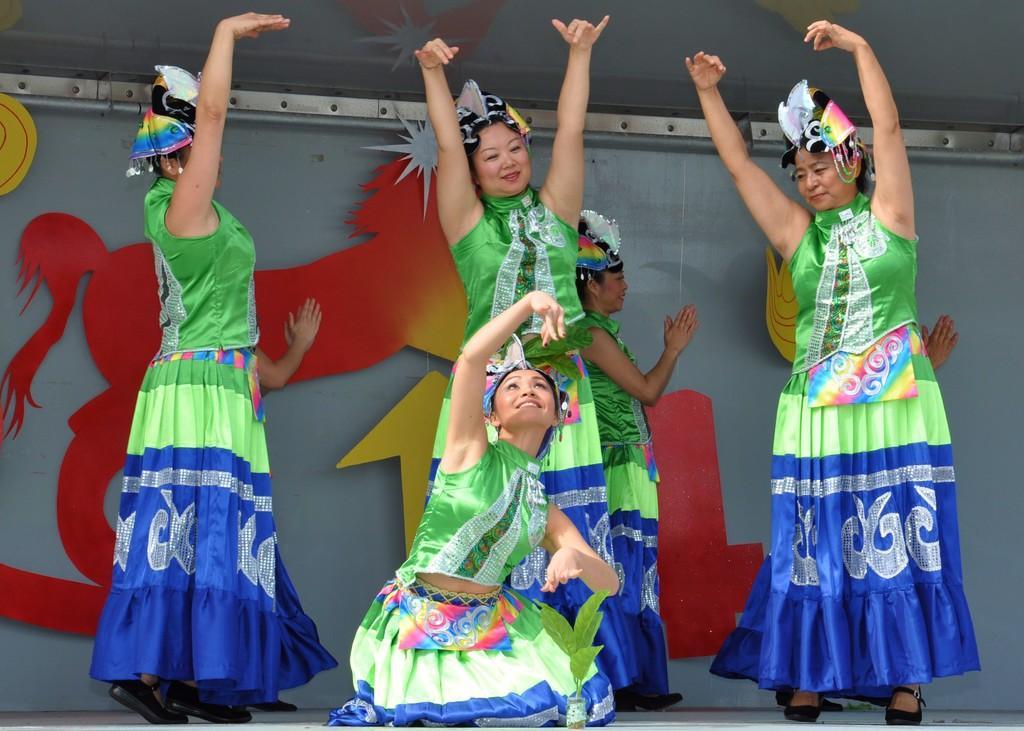In one or two sentences, can you explain what this image depicts? In this image, we can see persons wearing clothes and acting in a play in front of the wall. 